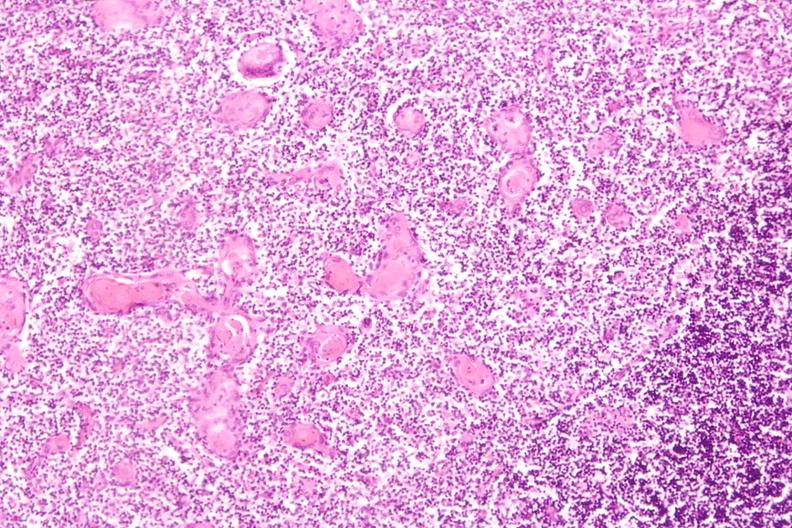s hematologic present?
Answer the question using a single word or phrase. Yes 